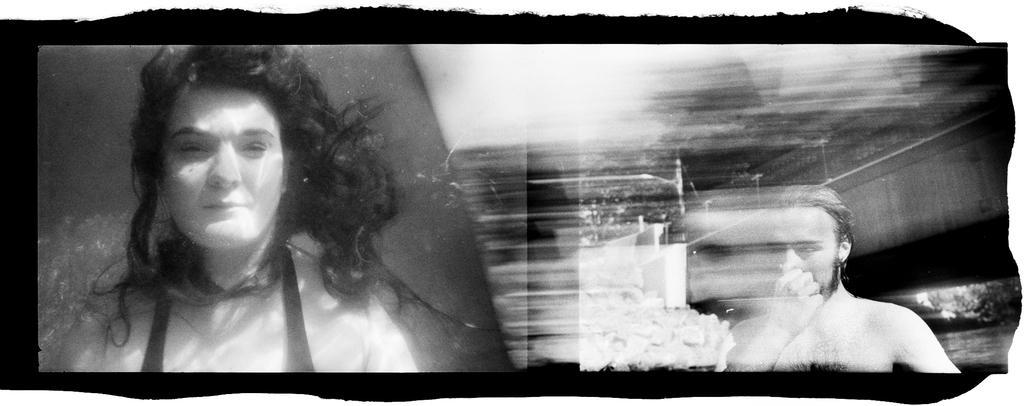Could you give a brief overview of what you see in this image? It is a black and white image. On the left side of the image there is a person under the water. On the right side of the image there is a person holding the nose. Behind him there is water. There are trees and the background of the image is blur. 